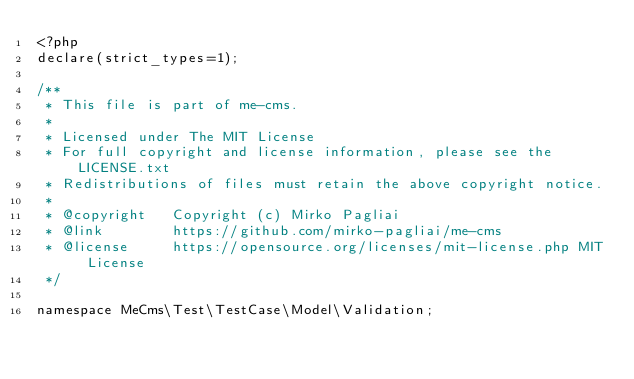<code> <loc_0><loc_0><loc_500><loc_500><_PHP_><?php
declare(strict_types=1);

/**
 * This file is part of me-cms.
 *
 * Licensed under The MIT License
 * For full copyright and license information, please see the LICENSE.txt
 * Redistributions of files must retain the above copyright notice.
 *
 * @copyright   Copyright (c) Mirko Pagliai
 * @link        https://github.com/mirko-pagliai/me-cms
 * @license     https://opensource.org/licenses/mit-license.php MIT License
 */

namespace MeCms\Test\TestCase\Model\Validation;
</code> 